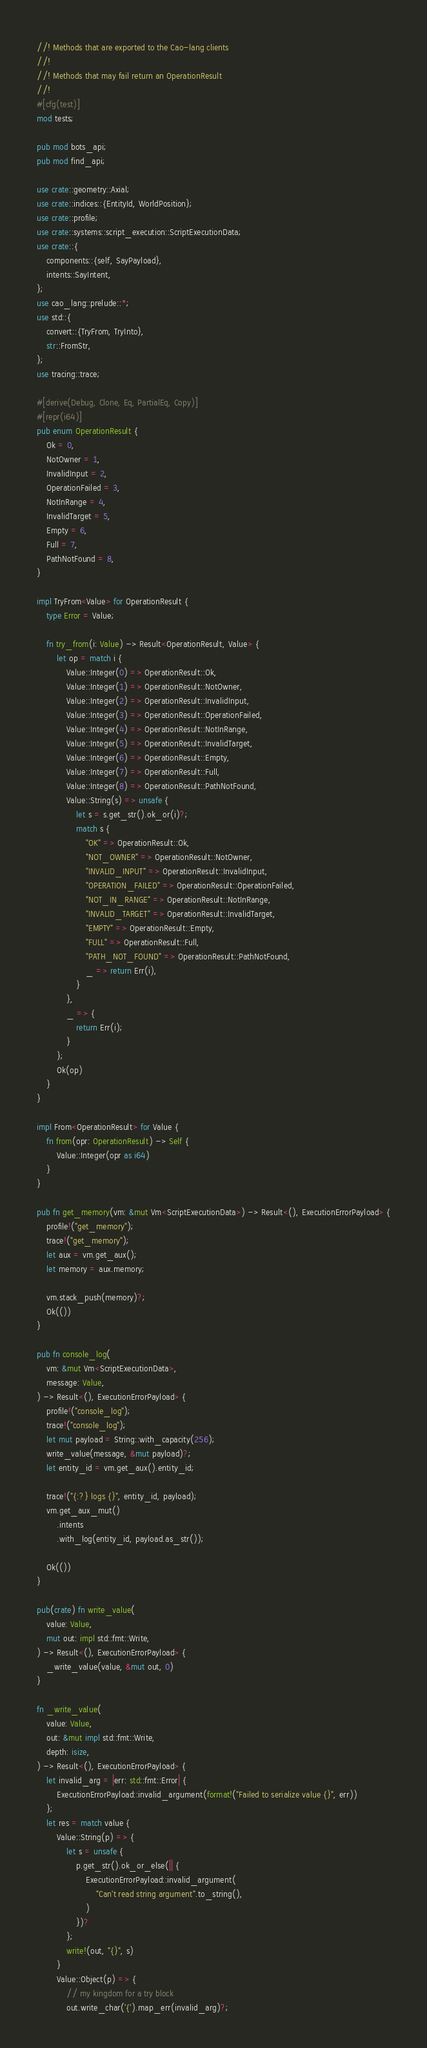Convert code to text. <code><loc_0><loc_0><loc_500><loc_500><_Rust_>//! Methods that are exported to the Cao-lang clients
//!
//! Methods that may fail return an OperationResult
//!
#[cfg(test)]
mod tests;

pub mod bots_api;
pub mod find_api;

use crate::geometry::Axial;
use crate::indices::{EntityId, WorldPosition};
use crate::profile;
use crate::systems::script_execution::ScriptExecutionData;
use crate::{
    components::{self, SayPayload},
    intents::SayIntent,
};
use cao_lang::prelude::*;
use std::{
    convert::{TryFrom, TryInto},
    str::FromStr,
};
use tracing::trace;

#[derive(Debug, Clone, Eq, PartialEq, Copy)]
#[repr(i64)]
pub enum OperationResult {
    Ok = 0,
    NotOwner = 1,
    InvalidInput = 2,
    OperationFailed = 3,
    NotInRange = 4,
    InvalidTarget = 5,
    Empty = 6,
    Full = 7,
    PathNotFound = 8,
}

impl TryFrom<Value> for OperationResult {
    type Error = Value;

    fn try_from(i: Value) -> Result<OperationResult, Value> {
        let op = match i {
            Value::Integer(0) => OperationResult::Ok,
            Value::Integer(1) => OperationResult::NotOwner,
            Value::Integer(2) => OperationResult::InvalidInput,
            Value::Integer(3) => OperationResult::OperationFailed,
            Value::Integer(4) => OperationResult::NotInRange,
            Value::Integer(5) => OperationResult::InvalidTarget,
            Value::Integer(6) => OperationResult::Empty,
            Value::Integer(7) => OperationResult::Full,
            Value::Integer(8) => OperationResult::PathNotFound,
            Value::String(s) => unsafe {
                let s = s.get_str().ok_or(i)?;
                match s {
                    "OK" => OperationResult::Ok,
                    "NOT_OWNER" => OperationResult::NotOwner,
                    "INVALID_INPUT" => OperationResult::InvalidInput,
                    "OPERATION_FAILED" => OperationResult::OperationFailed,
                    "NOT_IN_RANGE" => OperationResult::NotInRange,
                    "INVALID_TARGET" => OperationResult::InvalidTarget,
                    "EMPTY" => OperationResult::Empty,
                    "FULL" => OperationResult::Full,
                    "PATH_NOT_FOUND" => OperationResult::PathNotFound,
                    _ => return Err(i),
                }
            },
            _ => {
                return Err(i);
            }
        };
        Ok(op)
    }
}

impl From<OperationResult> for Value {
    fn from(opr: OperationResult) -> Self {
        Value::Integer(opr as i64)
    }
}

pub fn get_memory(vm: &mut Vm<ScriptExecutionData>) -> Result<(), ExecutionErrorPayload> {
    profile!("get_memory");
    trace!("get_memory");
    let aux = vm.get_aux();
    let memory = aux.memory;

    vm.stack_push(memory)?;
    Ok(())
}

pub fn console_log(
    vm: &mut Vm<ScriptExecutionData>,
    message: Value,
) -> Result<(), ExecutionErrorPayload> {
    profile!("console_log");
    trace!("console_log");
    let mut payload = String::with_capacity(256);
    write_value(message, &mut payload)?;
    let entity_id = vm.get_aux().entity_id;

    trace!("{:?} logs {}", entity_id, payload);
    vm.get_aux_mut()
        .intents
        .with_log(entity_id, payload.as_str());

    Ok(())
}

pub(crate) fn write_value(
    value: Value,
    mut out: impl std::fmt::Write,
) -> Result<(), ExecutionErrorPayload> {
    _write_value(value, &mut out, 0)
}

fn _write_value(
    value: Value,
    out: &mut impl std::fmt::Write,
    depth: isize,
) -> Result<(), ExecutionErrorPayload> {
    let invalid_arg = |err: std::fmt::Error| {
        ExecutionErrorPayload::invalid_argument(format!("Failed to serialize value {}", err))
    };
    let res = match value {
        Value::String(p) => {
            let s = unsafe {
                p.get_str().ok_or_else(|| {
                    ExecutionErrorPayload::invalid_argument(
                        "Can't read string argument".to_string(),
                    )
                })?
            };
            write!(out, "{}", s)
        }
        Value::Object(p) => {
            // my kingdom for a try block
            out.write_char('{').map_err(invalid_arg)?;</code> 